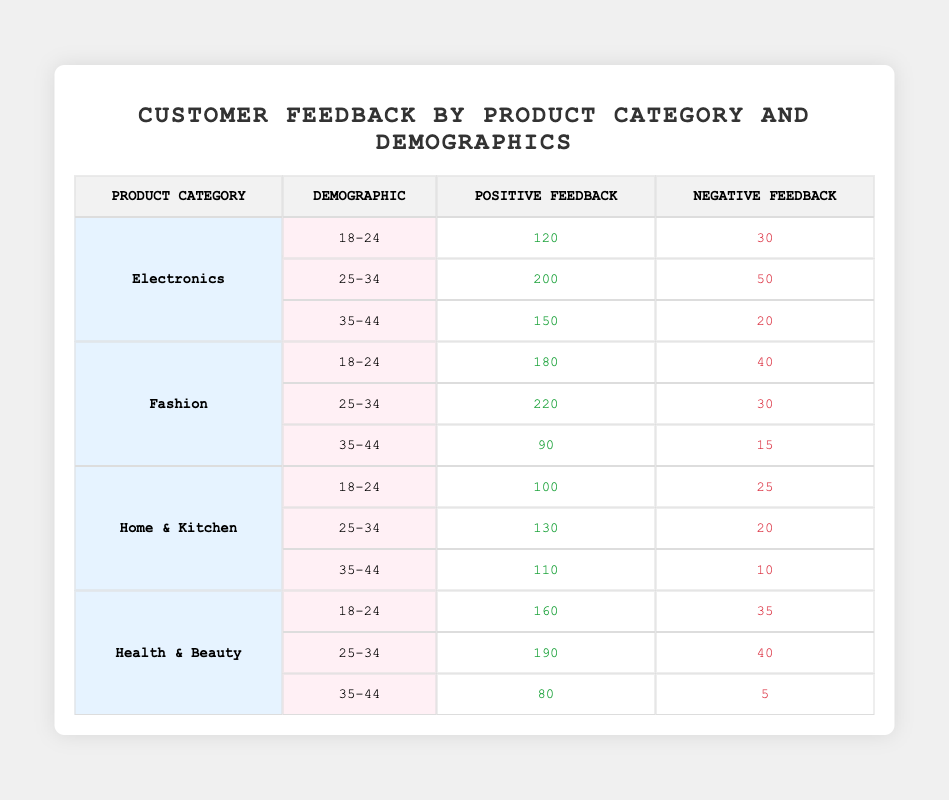What is the total positive feedback for the Fashion category? To find the total positive feedback for the Fashion category, add the positive feedback values for all demographics in this category: 180 (18-24) + 220 (25-34) + 90 (35-44) = 490.
Answer: 490 Which demographic provided the most negative feedback for Electronics? To identify the demographic with the most negative feedback in the Electronics category, compare the negative feedback values for each demographic: 30 (18-24), 50 (25-34), and 20 (35-44). The highest value is 50 from the 25-34 demographic.
Answer: 25-34 Is the negative feedback higher for the 25-34 demographic in Health & Beauty compared to Electronics? For Health & Beauty, the negative feedback for the 25-34 demographic is 40, and for Electronics, it is 50. Since 40 is less than 50, the statement is false.
Answer: No What is the average positive feedback across all demographics for Home & Kitchen? To calculate the average positive feedback for Home & Kitchen, first sum the positive feedback values: 100 (18-24) + 130 (25-34) + 110 (35-44) = 340. There are 3 values, so average = 340 / 3 = approximately 113.33.
Answer: 113.33 Which product category has the lowest overall negative feedback? First, calculate the total negative feedback for each product category: Electronics (30 + 50 + 20 = 100), Fashion (40 + 30 + 15 = 85), Home & Kitchen (25 + 20 + 10 = 55), Health & Beauty (35 + 40 + 5 = 80). The category with the lowest total negative feedback is Home & Kitchen with 55.
Answer: Home & Kitchen How much more positive feedback was received from the 18-24 demographic for Fashion compared to Home & Kitchen? The positive feedback for Fashion from the 18-24 demographic is 180, while for Home & Kitchen, it is 100. The difference is calculated as 180 - 100 = 80.
Answer: 80 Is the positive feedback for the 35-44 demographic higher in Health & Beauty than in Fashion? For Health & Beauty, the positive feedback for the 35-44 demographic is 80, while for Fashion, it is 90. Since 80 is less than 90, the statement is false.
Answer: No What is the total positive feedback for customers aged 25-34 across all product categories? Adding positive feedback values from the 25-34 demographic across all categories: Electronics = 200, Fashion = 220, Home & Kitchen = 130, and Health & Beauty = 190. Total = 200 + 220 + 130 + 190 = 740.
Answer: 740 Which demographic has the highest positive feedback in the Electronics category? The positive feedback values for the Electronics category are: 120 (18-24), 200 (25-34), and 150 (35-44). The highest value is 200 from the 25-34 demographic.
Answer: 25-34 